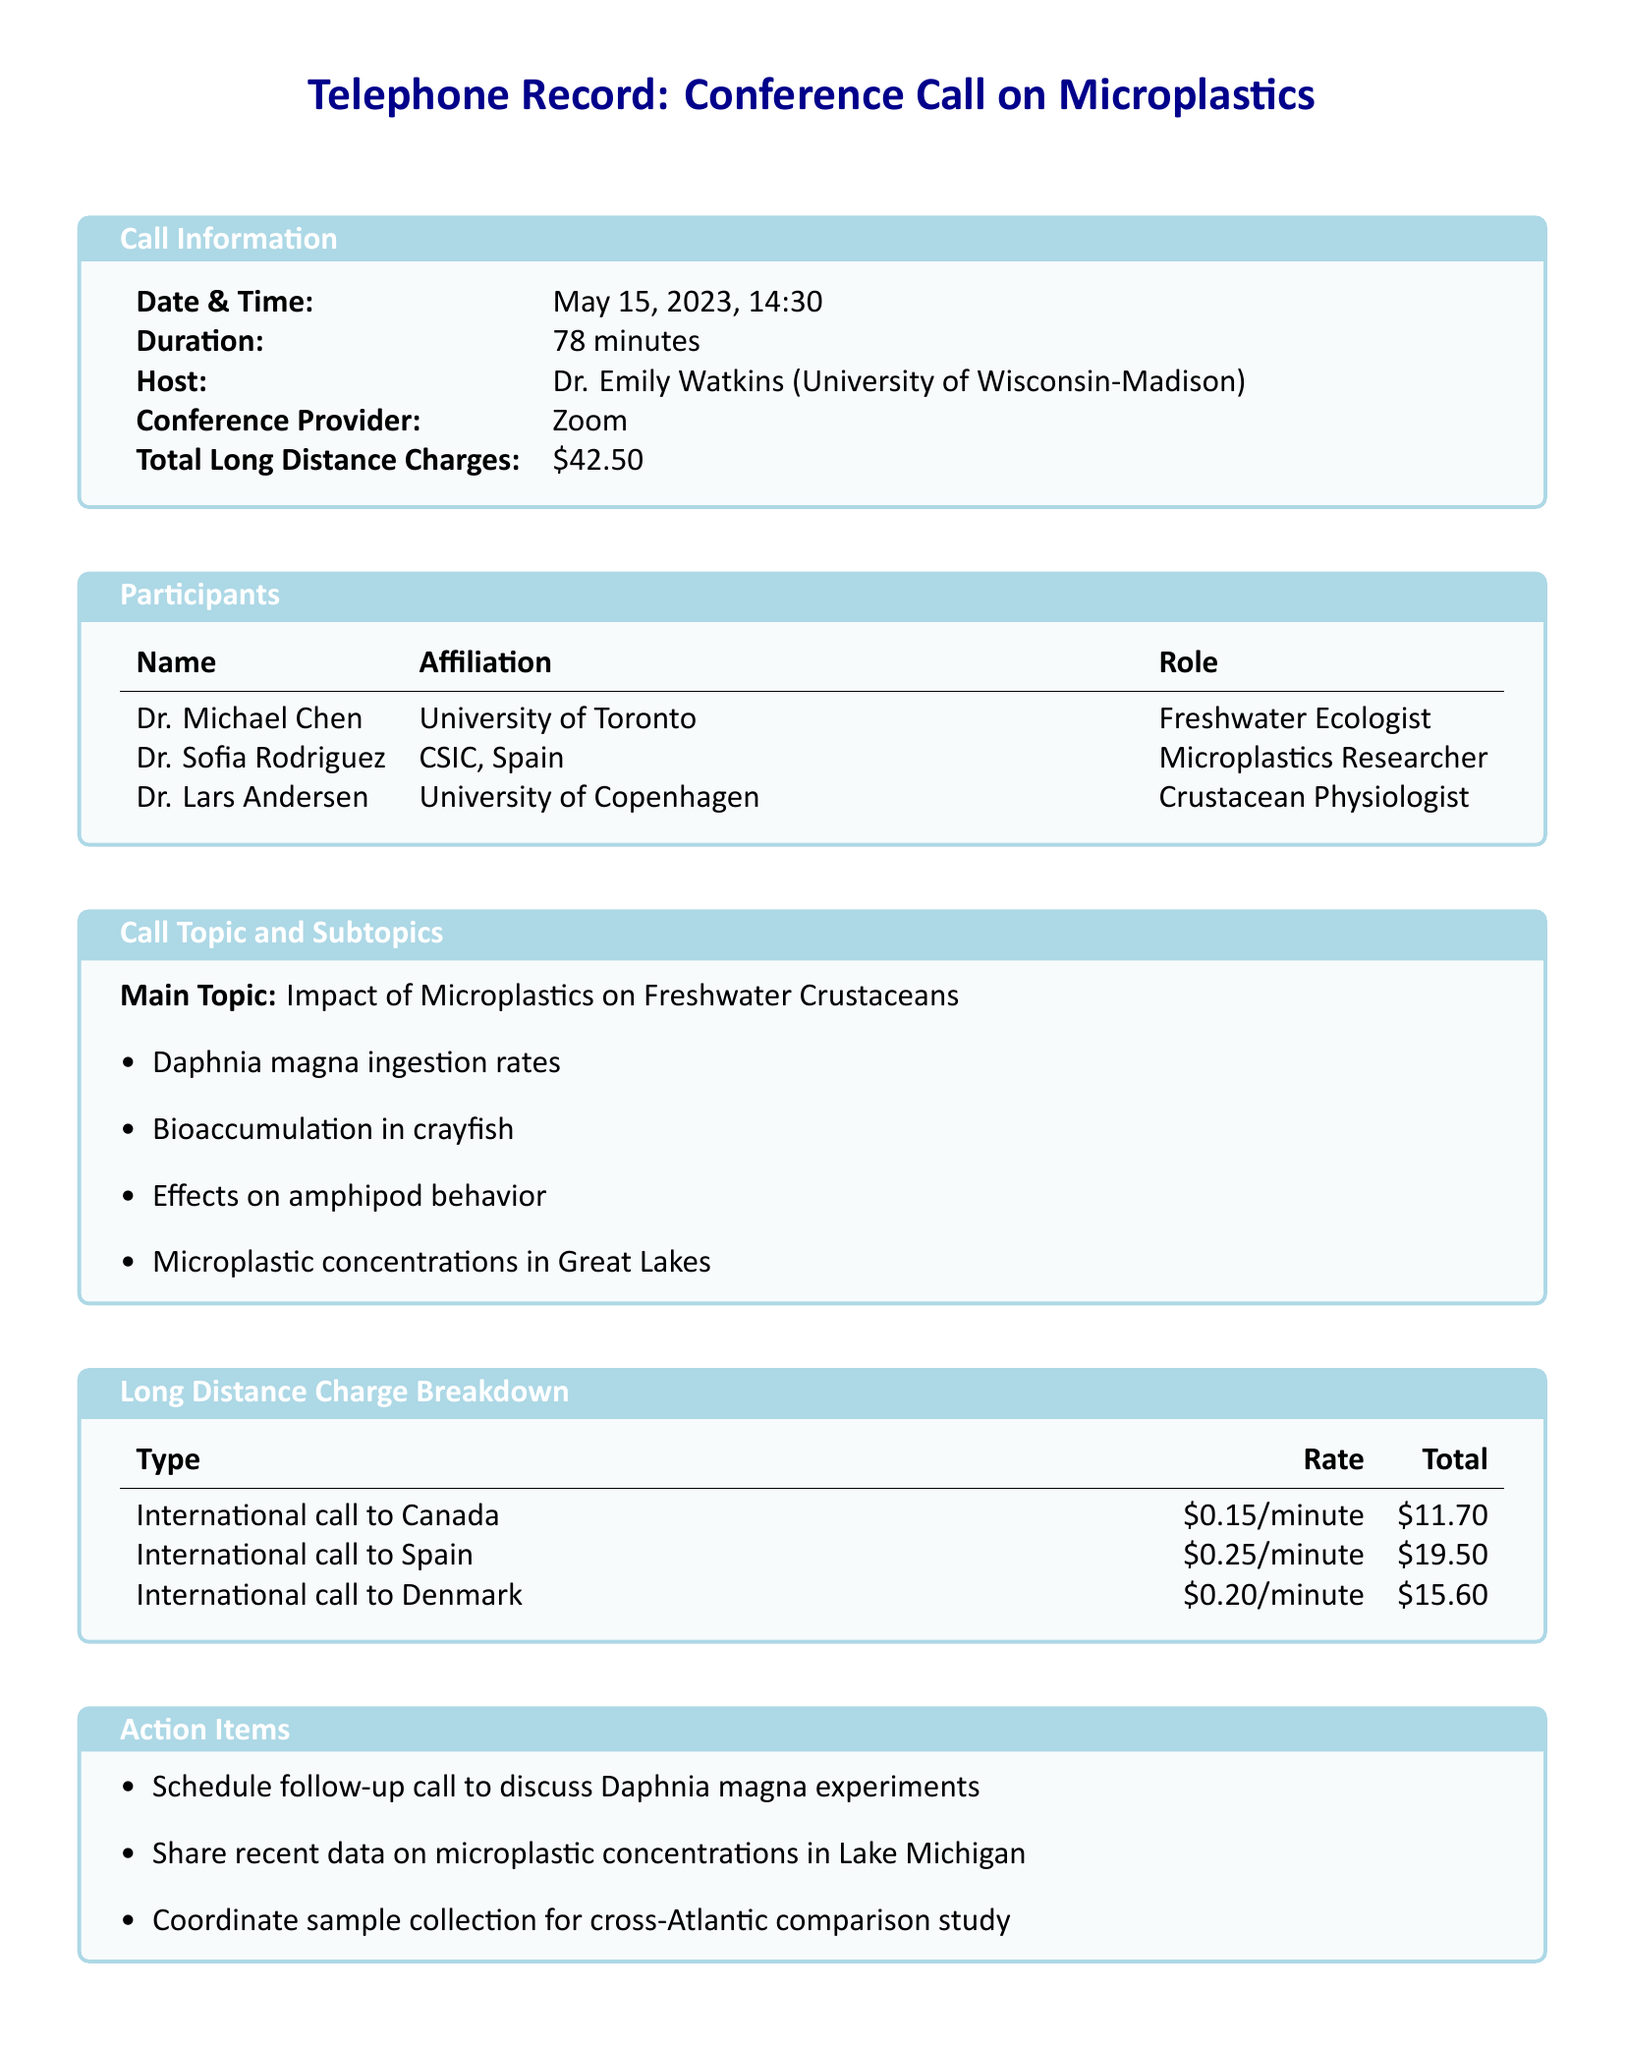What is the date and time of the conference call? The date and time are specified in the call information section of the document.
Answer: May 15, 2023, 14:30 Who is the host of the conference call? The host's name is listed in the call information section.
Answer: Dr. Emily Watkins What is the total duration of the conference call? The duration is provided in the call information section.
Answer: 78 minutes What is the total charge for long-distance calls? The total charge is detailed in the call information section.
Answer: $42.50 How many participants are listed in the document? The number of participants is calculated from the participants section of the document.
Answer: 3 What type of call incurred the highest charge? The long-distance charge breakdown lists each call type and their totals.
Answer: International call to Spain What was the rate per minute for the call to Denmark? The rate is specified in the long-distance charge breakdown section.
Answer: $0.20/minute What action item relates to Daphnia magna? One of the action items specifically mentions Daphnia magna experiments.
Answer: Schedule follow-up call What is the main topic of the conference call? The main topic is provided in the call topic section of the document.
Answer: Impact of Microplastics on Freshwater Crustaceans 